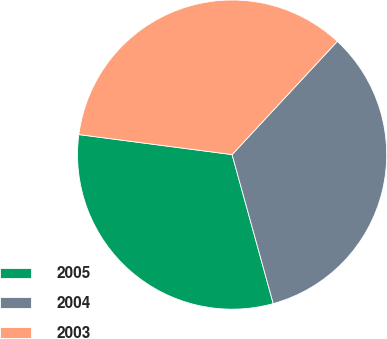<chart> <loc_0><loc_0><loc_500><loc_500><pie_chart><fcel>2005<fcel>2004<fcel>2003<nl><fcel>31.36%<fcel>33.8%<fcel>34.85%<nl></chart> 